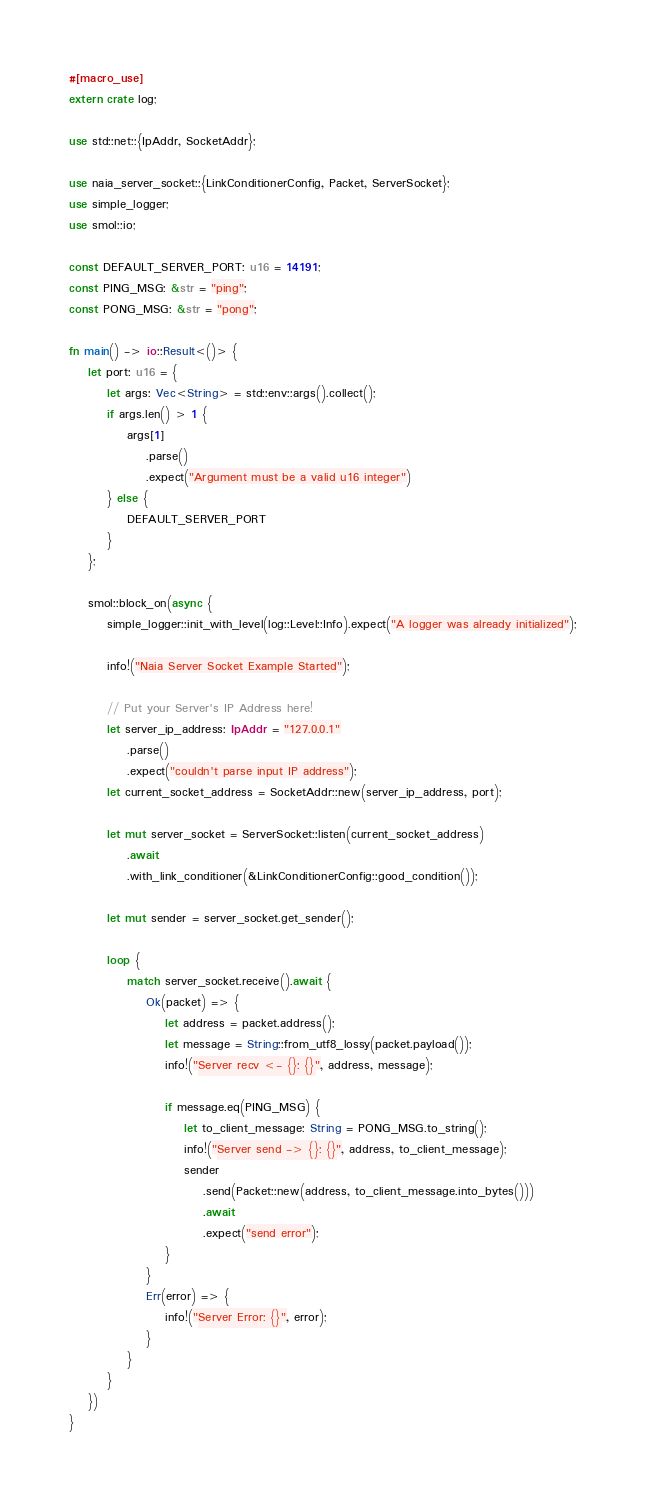Convert code to text. <code><loc_0><loc_0><loc_500><loc_500><_Rust_>#[macro_use]
extern crate log;

use std::net::{IpAddr, SocketAddr};

use naia_server_socket::{LinkConditionerConfig, Packet, ServerSocket};
use simple_logger;
use smol::io;

const DEFAULT_SERVER_PORT: u16 = 14191;
const PING_MSG: &str = "ping";
const PONG_MSG: &str = "pong";

fn main() -> io::Result<()> {
    let port: u16 = {
        let args: Vec<String> = std::env::args().collect();
        if args.len() > 1 {
            args[1]
                .parse()
                .expect("Argument must be a valid u16 integer")
        } else {
            DEFAULT_SERVER_PORT
        }
    };

    smol::block_on(async {
        simple_logger::init_with_level(log::Level::Info).expect("A logger was already initialized");

        info!("Naia Server Socket Example Started");

        // Put your Server's IP Address here!
        let server_ip_address: IpAddr = "127.0.0.1"
            .parse()
            .expect("couldn't parse input IP address");
        let current_socket_address = SocketAddr::new(server_ip_address, port);

        let mut server_socket = ServerSocket::listen(current_socket_address)
            .await
            .with_link_conditioner(&LinkConditionerConfig::good_condition());

        let mut sender = server_socket.get_sender();

        loop {
            match server_socket.receive().await {
                Ok(packet) => {
                    let address = packet.address();
                    let message = String::from_utf8_lossy(packet.payload());
                    info!("Server recv <- {}: {}", address, message);

                    if message.eq(PING_MSG) {
                        let to_client_message: String = PONG_MSG.to_string();
                        info!("Server send -> {}: {}", address, to_client_message);
                        sender
                            .send(Packet::new(address, to_client_message.into_bytes()))
                            .await
                            .expect("send error");
                    }
                }
                Err(error) => {
                    info!("Server Error: {}", error);
                }
            }
        }
    })
}
</code> 